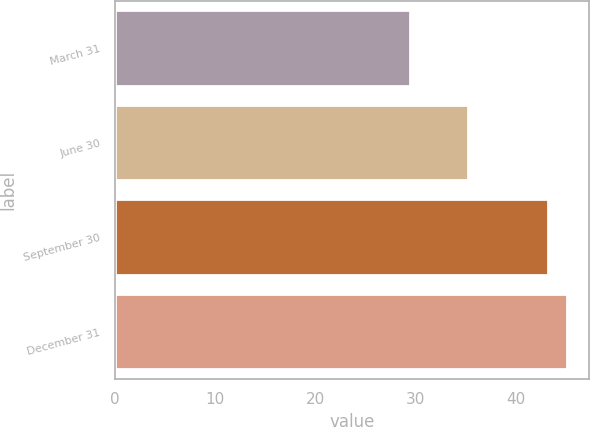Convert chart. <chart><loc_0><loc_0><loc_500><loc_500><bar_chart><fcel>March 31<fcel>June 30<fcel>September 30<fcel>December 31<nl><fcel>29.46<fcel>35.21<fcel>43.14<fcel>45.05<nl></chart> 